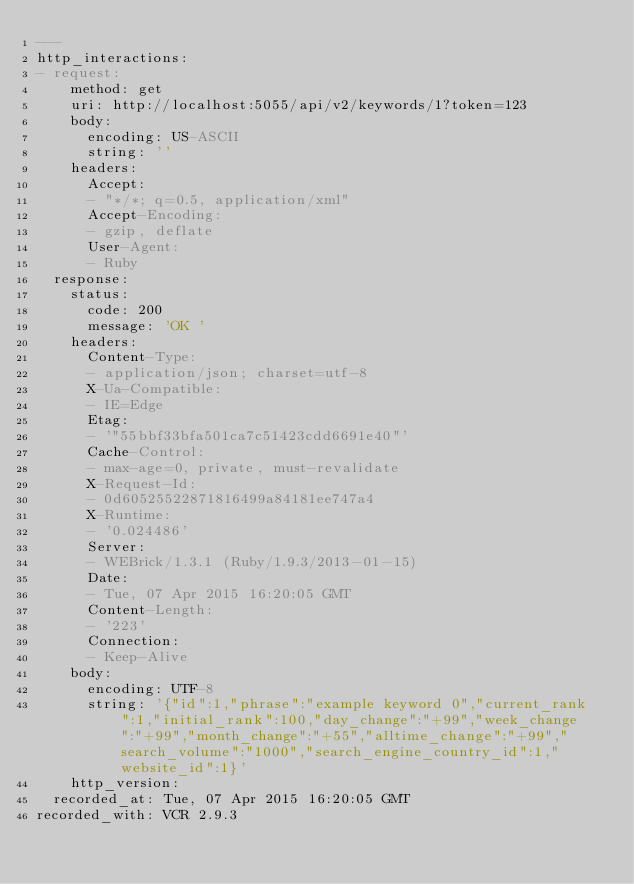Convert code to text. <code><loc_0><loc_0><loc_500><loc_500><_YAML_>---
http_interactions:
- request:
    method: get
    uri: http://localhost:5055/api/v2/keywords/1?token=123
    body:
      encoding: US-ASCII
      string: ''
    headers:
      Accept:
      - "*/*; q=0.5, application/xml"
      Accept-Encoding:
      - gzip, deflate
      User-Agent:
      - Ruby
  response:
    status:
      code: 200
      message: 'OK '
    headers:
      Content-Type:
      - application/json; charset=utf-8
      X-Ua-Compatible:
      - IE=Edge
      Etag:
      - '"55bbf33bfa501ca7c51423cdd6691e40"'
      Cache-Control:
      - max-age=0, private, must-revalidate
      X-Request-Id:
      - 0d60525522871816499a84181ee747a4
      X-Runtime:
      - '0.024486'
      Server:
      - WEBrick/1.3.1 (Ruby/1.9.3/2013-01-15)
      Date:
      - Tue, 07 Apr 2015 16:20:05 GMT
      Content-Length:
      - '223'
      Connection:
      - Keep-Alive
    body:
      encoding: UTF-8
      string: '{"id":1,"phrase":"example keyword 0","current_rank":1,"initial_rank":100,"day_change":"+99","week_change":"+99","month_change":"+55","alltime_change":"+99","search_volume":"1000","search_engine_country_id":1,"website_id":1}'
    http_version: 
  recorded_at: Tue, 07 Apr 2015 16:20:05 GMT
recorded_with: VCR 2.9.3
</code> 